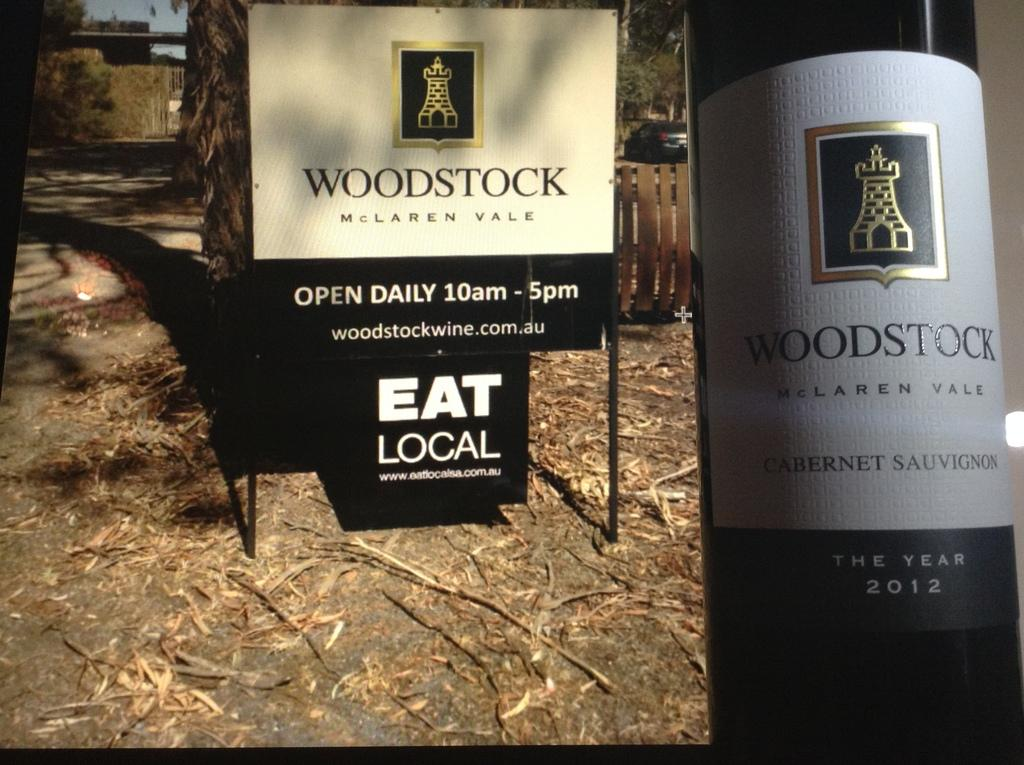Provide a one-sentence caption for the provided image. A sign for Woodstock winery next to an image of their Woodstock wine bottle. 